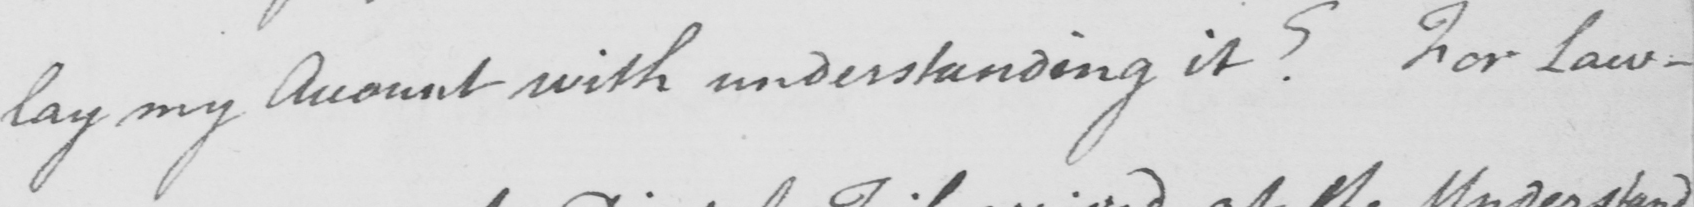What text is written in this handwritten line? lay my Account with understanding it ?  For Law- 